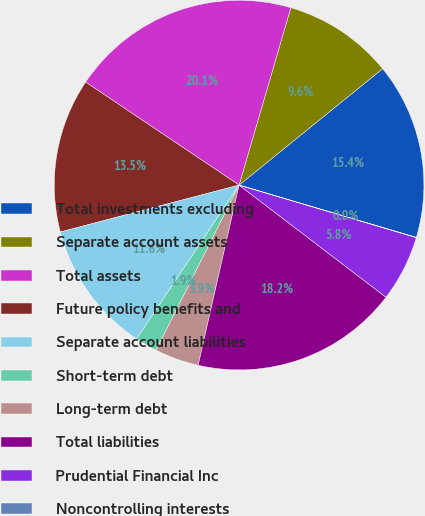Convert chart to OTSL. <chart><loc_0><loc_0><loc_500><loc_500><pie_chart><fcel>Total investments excluding<fcel>Separate account assets<fcel>Total assets<fcel>Future policy benefits and<fcel>Separate account liabilities<fcel>Short-term debt<fcel>Long-term debt<fcel>Total liabilities<fcel>Prudential Financial Inc<fcel>Noncontrolling interests<nl><fcel>15.41%<fcel>9.64%<fcel>20.11%<fcel>13.49%<fcel>11.56%<fcel>1.94%<fcel>3.86%<fcel>18.18%<fcel>5.79%<fcel>0.02%<nl></chart> 